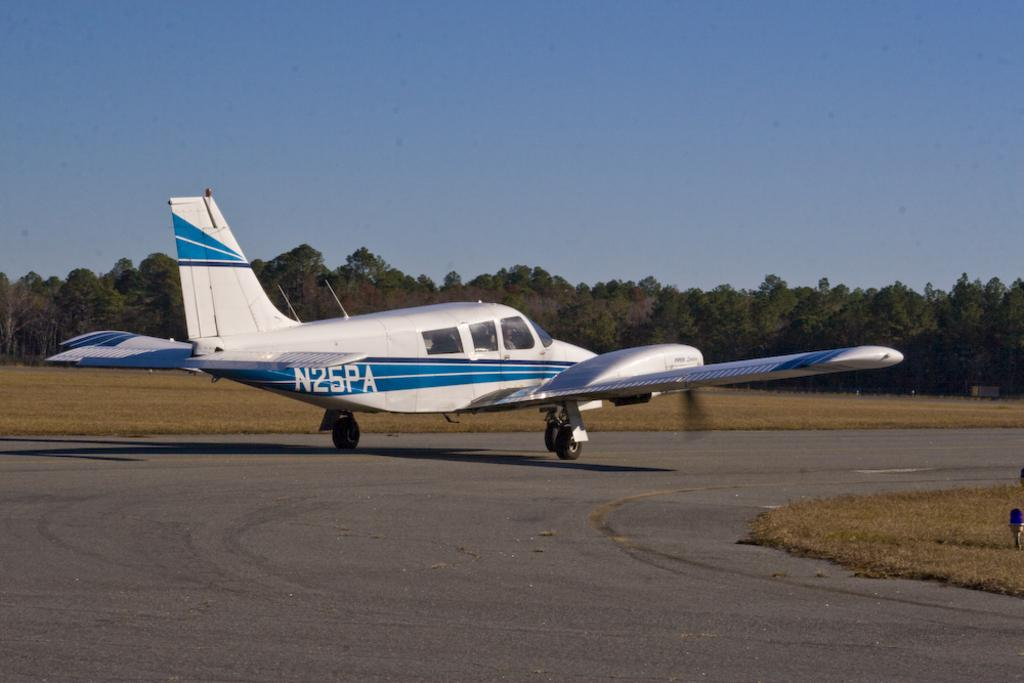<image>
Provide a brief description of the given image. A private plane is identified by the number N25PA. 